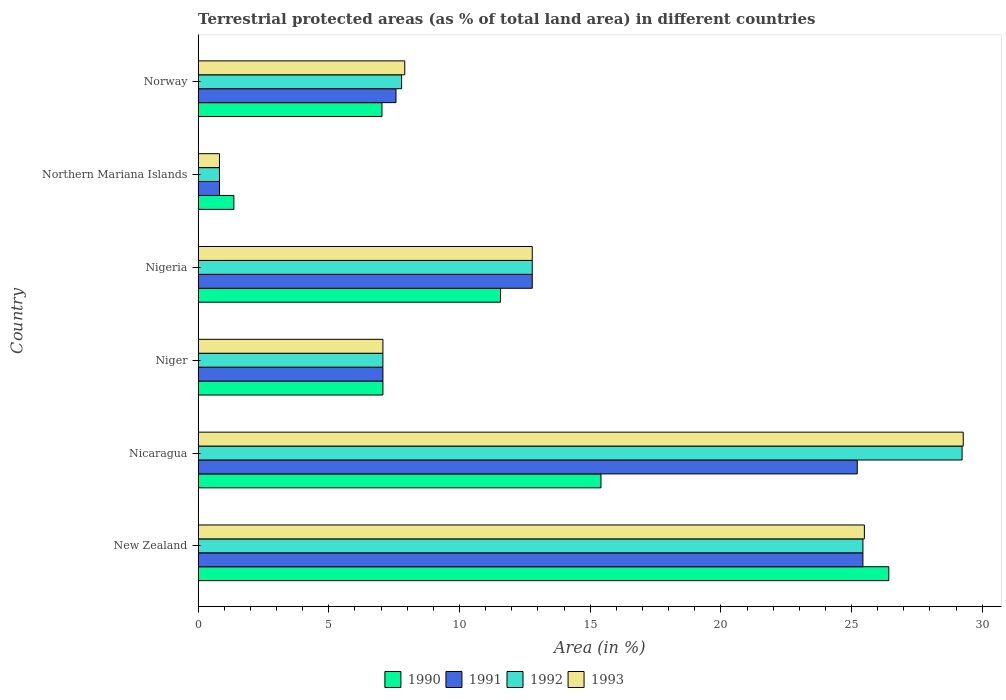How many groups of bars are there?
Keep it short and to the point. 6. How many bars are there on the 1st tick from the top?
Your answer should be compact. 4. How many bars are there on the 5th tick from the bottom?
Keep it short and to the point. 4. What is the label of the 6th group of bars from the top?
Provide a short and direct response. New Zealand. What is the percentage of terrestrial protected land in 1993 in Nigeria?
Offer a very short reply. 12.78. Across all countries, what is the maximum percentage of terrestrial protected land in 1991?
Keep it short and to the point. 25.44. Across all countries, what is the minimum percentage of terrestrial protected land in 1993?
Make the answer very short. 0.82. In which country was the percentage of terrestrial protected land in 1991 maximum?
Make the answer very short. New Zealand. In which country was the percentage of terrestrial protected land in 1991 minimum?
Provide a succinct answer. Northern Mariana Islands. What is the total percentage of terrestrial protected land in 1990 in the graph?
Make the answer very short. 68.88. What is the difference between the percentage of terrestrial protected land in 1993 in New Zealand and that in Nigeria?
Provide a succinct answer. 12.71. What is the difference between the percentage of terrestrial protected land in 1990 in Niger and the percentage of terrestrial protected land in 1991 in Norway?
Provide a succinct answer. -0.5. What is the average percentage of terrestrial protected land in 1990 per country?
Your answer should be compact. 11.48. What is the difference between the percentage of terrestrial protected land in 1991 and percentage of terrestrial protected land in 1992 in New Zealand?
Keep it short and to the point. -0. In how many countries, is the percentage of terrestrial protected land in 1992 greater than 25 %?
Ensure brevity in your answer.  2. What is the ratio of the percentage of terrestrial protected land in 1993 in New Zealand to that in Northern Mariana Islands?
Make the answer very short. 31.27. Is the percentage of terrestrial protected land in 1990 in Northern Mariana Islands less than that in Norway?
Give a very brief answer. Yes. What is the difference between the highest and the second highest percentage of terrestrial protected land in 1993?
Provide a short and direct response. 3.78. What is the difference between the highest and the lowest percentage of terrestrial protected land in 1992?
Provide a succinct answer. 28.41. In how many countries, is the percentage of terrestrial protected land in 1990 greater than the average percentage of terrestrial protected land in 1990 taken over all countries?
Offer a terse response. 3. Is it the case that in every country, the sum of the percentage of terrestrial protected land in 1990 and percentage of terrestrial protected land in 1993 is greater than the sum of percentage of terrestrial protected land in 1992 and percentage of terrestrial protected land in 1991?
Provide a short and direct response. No. What does the 2nd bar from the top in Niger represents?
Make the answer very short. 1992. Are all the bars in the graph horizontal?
Offer a terse response. Yes. How many countries are there in the graph?
Provide a short and direct response. 6. What is the difference between two consecutive major ticks on the X-axis?
Keep it short and to the point. 5. Are the values on the major ticks of X-axis written in scientific E-notation?
Your response must be concise. No. Does the graph contain grids?
Make the answer very short. No. Where does the legend appear in the graph?
Offer a terse response. Bottom center. What is the title of the graph?
Offer a very short reply. Terrestrial protected areas (as % of total land area) in different countries. What is the label or title of the X-axis?
Keep it short and to the point. Area (in %). What is the label or title of the Y-axis?
Make the answer very short. Country. What is the Area (in %) of 1990 in New Zealand?
Make the answer very short. 26.42. What is the Area (in %) in 1991 in New Zealand?
Provide a succinct answer. 25.44. What is the Area (in %) in 1992 in New Zealand?
Provide a succinct answer. 25.44. What is the Area (in %) of 1993 in New Zealand?
Your answer should be compact. 25.49. What is the Area (in %) in 1990 in Nicaragua?
Your answer should be very brief. 15.41. What is the Area (in %) in 1991 in Nicaragua?
Your response must be concise. 25.22. What is the Area (in %) of 1992 in Nicaragua?
Provide a succinct answer. 29.23. What is the Area (in %) in 1993 in Nicaragua?
Keep it short and to the point. 29.27. What is the Area (in %) of 1990 in Niger?
Keep it short and to the point. 7.07. What is the Area (in %) of 1991 in Niger?
Provide a short and direct response. 7.07. What is the Area (in %) in 1992 in Niger?
Make the answer very short. 7.07. What is the Area (in %) of 1993 in Niger?
Offer a very short reply. 7.07. What is the Area (in %) in 1990 in Nigeria?
Your answer should be very brief. 11.57. What is the Area (in %) in 1991 in Nigeria?
Your answer should be compact. 12.78. What is the Area (in %) in 1992 in Nigeria?
Provide a short and direct response. 12.78. What is the Area (in %) of 1993 in Nigeria?
Provide a short and direct response. 12.78. What is the Area (in %) in 1990 in Northern Mariana Islands?
Keep it short and to the point. 1.37. What is the Area (in %) in 1991 in Northern Mariana Islands?
Offer a terse response. 0.82. What is the Area (in %) of 1992 in Northern Mariana Islands?
Provide a succinct answer. 0.82. What is the Area (in %) of 1993 in Northern Mariana Islands?
Ensure brevity in your answer.  0.82. What is the Area (in %) in 1990 in Norway?
Offer a very short reply. 7.03. What is the Area (in %) of 1991 in Norway?
Offer a terse response. 7.57. What is the Area (in %) of 1992 in Norway?
Provide a short and direct response. 7.78. What is the Area (in %) in 1993 in Norway?
Offer a terse response. 7.9. Across all countries, what is the maximum Area (in %) of 1990?
Your answer should be very brief. 26.42. Across all countries, what is the maximum Area (in %) in 1991?
Your answer should be compact. 25.44. Across all countries, what is the maximum Area (in %) of 1992?
Ensure brevity in your answer.  29.23. Across all countries, what is the maximum Area (in %) in 1993?
Make the answer very short. 29.27. Across all countries, what is the minimum Area (in %) of 1990?
Offer a terse response. 1.37. Across all countries, what is the minimum Area (in %) in 1991?
Your answer should be compact. 0.82. Across all countries, what is the minimum Area (in %) of 1992?
Offer a very short reply. 0.82. Across all countries, what is the minimum Area (in %) in 1993?
Offer a terse response. 0.82. What is the total Area (in %) in 1990 in the graph?
Ensure brevity in your answer.  68.88. What is the total Area (in %) in 1991 in the graph?
Provide a succinct answer. 78.89. What is the total Area (in %) of 1992 in the graph?
Offer a very short reply. 83.12. What is the total Area (in %) of 1993 in the graph?
Your answer should be very brief. 83.34. What is the difference between the Area (in %) in 1990 in New Zealand and that in Nicaragua?
Keep it short and to the point. 11.01. What is the difference between the Area (in %) in 1991 in New Zealand and that in Nicaragua?
Provide a succinct answer. 0.22. What is the difference between the Area (in %) in 1992 in New Zealand and that in Nicaragua?
Make the answer very short. -3.79. What is the difference between the Area (in %) in 1993 in New Zealand and that in Nicaragua?
Your answer should be compact. -3.78. What is the difference between the Area (in %) in 1990 in New Zealand and that in Niger?
Give a very brief answer. 19.36. What is the difference between the Area (in %) in 1991 in New Zealand and that in Niger?
Keep it short and to the point. 18.37. What is the difference between the Area (in %) in 1992 in New Zealand and that in Niger?
Provide a short and direct response. 18.37. What is the difference between the Area (in %) in 1993 in New Zealand and that in Niger?
Your answer should be compact. 18.42. What is the difference between the Area (in %) in 1990 in New Zealand and that in Nigeria?
Your answer should be compact. 14.86. What is the difference between the Area (in %) in 1991 in New Zealand and that in Nigeria?
Your answer should be compact. 12.65. What is the difference between the Area (in %) of 1992 in New Zealand and that in Nigeria?
Offer a terse response. 12.65. What is the difference between the Area (in %) of 1993 in New Zealand and that in Nigeria?
Ensure brevity in your answer.  12.71. What is the difference between the Area (in %) in 1990 in New Zealand and that in Northern Mariana Islands?
Keep it short and to the point. 25.06. What is the difference between the Area (in %) of 1991 in New Zealand and that in Northern Mariana Islands?
Your answer should be very brief. 24.62. What is the difference between the Area (in %) in 1992 in New Zealand and that in Northern Mariana Islands?
Make the answer very short. 24.62. What is the difference between the Area (in %) of 1993 in New Zealand and that in Northern Mariana Islands?
Offer a terse response. 24.68. What is the difference between the Area (in %) in 1990 in New Zealand and that in Norway?
Offer a terse response. 19.39. What is the difference between the Area (in %) in 1991 in New Zealand and that in Norway?
Ensure brevity in your answer.  17.87. What is the difference between the Area (in %) of 1992 in New Zealand and that in Norway?
Provide a succinct answer. 17.65. What is the difference between the Area (in %) of 1993 in New Zealand and that in Norway?
Provide a short and direct response. 17.59. What is the difference between the Area (in %) of 1990 in Nicaragua and that in Niger?
Offer a terse response. 8.34. What is the difference between the Area (in %) of 1991 in Nicaragua and that in Niger?
Your answer should be very brief. 18.15. What is the difference between the Area (in %) of 1992 in Nicaragua and that in Niger?
Ensure brevity in your answer.  22.16. What is the difference between the Area (in %) of 1993 in Nicaragua and that in Niger?
Provide a short and direct response. 22.2. What is the difference between the Area (in %) in 1990 in Nicaragua and that in Nigeria?
Provide a succinct answer. 3.84. What is the difference between the Area (in %) of 1991 in Nicaragua and that in Nigeria?
Offer a terse response. 12.44. What is the difference between the Area (in %) of 1992 in Nicaragua and that in Nigeria?
Keep it short and to the point. 16.45. What is the difference between the Area (in %) in 1993 in Nicaragua and that in Nigeria?
Keep it short and to the point. 16.49. What is the difference between the Area (in %) in 1990 in Nicaragua and that in Northern Mariana Islands?
Offer a terse response. 14.05. What is the difference between the Area (in %) of 1991 in Nicaragua and that in Northern Mariana Islands?
Your answer should be compact. 24.4. What is the difference between the Area (in %) in 1992 in Nicaragua and that in Northern Mariana Islands?
Your answer should be compact. 28.41. What is the difference between the Area (in %) of 1993 in Nicaragua and that in Northern Mariana Islands?
Keep it short and to the point. 28.46. What is the difference between the Area (in %) of 1990 in Nicaragua and that in Norway?
Ensure brevity in your answer.  8.38. What is the difference between the Area (in %) of 1991 in Nicaragua and that in Norway?
Keep it short and to the point. 17.65. What is the difference between the Area (in %) of 1992 in Nicaragua and that in Norway?
Your response must be concise. 21.45. What is the difference between the Area (in %) in 1993 in Nicaragua and that in Norway?
Ensure brevity in your answer.  21.37. What is the difference between the Area (in %) of 1991 in Niger and that in Nigeria?
Your answer should be very brief. -5.71. What is the difference between the Area (in %) of 1992 in Niger and that in Nigeria?
Give a very brief answer. -5.71. What is the difference between the Area (in %) in 1993 in Niger and that in Nigeria?
Offer a terse response. -5.71. What is the difference between the Area (in %) of 1990 in Niger and that in Northern Mariana Islands?
Give a very brief answer. 5.7. What is the difference between the Area (in %) in 1991 in Niger and that in Northern Mariana Islands?
Ensure brevity in your answer.  6.25. What is the difference between the Area (in %) of 1992 in Niger and that in Northern Mariana Islands?
Provide a short and direct response. 6.25. What is the difference between the Area (in %) of 1993 in Niger and that in Northern Mariana Islands?
Your answer should be compact. 6.25. What is the difference between the Area (in %) in 1990 in Niger and that in Norway?
Provide a short and direct response. 0.04. What is the difference between the Area (in %) of 1991 in Niger and that in Norway?
Offer a terse response. -0.5. What is the difference between the Area (in %) of 1992 in Niger and that in Norway?
Your answer should be very brief. -0.71. What is the difference between the Area (in %) of 1993 in Niger and that in Norway?
Make the answer very short. -0.84. What is the difference between the Area (in %) in 1990 in Nigeria and that in Northern Mariana Islands?
Give a very brief answer. 10.2. What is the difference between the Area (in %) of 1991 in Nigeria and that in Northern Mariana Islands?
Your response must be concise. 11.97. What is the difference between the Area (in %) in 1992 in Nigeria and that in Northern Mariana Islands?
Your answer should be very brief. 11.97. What is the difference between the Area (in %) in 1993 in Nigeria and that in Northern Mariana Islands?
Give a very brief answer. 11.97. What is the difference between the Area (in %) of 1990 in Nigeria and that in Norway?
Offer a very short reply. 4.54. What is the difference between the Area (in %) of 1991 in Nigeria and that in Norway?
Ensure brevity in your answer.  5.21. What is the difference between the Area (in %) of 1992 in Nigeria and that in Norway?
Keep it short and to the point. 5. What is the difference between the Area (in %) in 1993 in Nigeria and that in Norway?
Give a very brief answer. 4.88. What is the difference between the Area (in %) in 1990 in Northern Mariana Islands and that in Norway?
Offer a terse response. -5.67. What is the difference between the Area (in %) of 1991 in Northern Mariana Islands and that in Norway?
Give a very brief answer. -6.75. What is the difference between the Area (in %) in 1992 in Northern Mariana Islands and that in Norway?
Your answer should be very brief. -6.97. What is the difference between the Area (in %) of 1993 in Northern Mariana Islands and that in Norway?
Ensure brevity in your answer.  -7.09. What is the difference between the Area (in %) in 1990 in New Zealand and the Area (in %) in 1991 in Nicaragua?
Your answer should be compact. 1.21. What is the difference between the Area (in %) in 1990 in New Zealand and the Area (in %) in 1992 in Nicaragua?
Provide a succinct answer. -2.81. What is the difference between the Area (in %) of 1990 in New Zealand and the Area (in %) of 1993 in Nicaragua?
Offer a terse response. -2.85. What is the difference between the Area (in %) in 1991 in New Zealand and the Area (in %) in 1992 in Nicaragua?
Make the answer very short. -3.79. What is the difference between the Area (in %) of 1991 in New Zealand and the Area (in %) of 1993 in Nicaragua?
Give a very brief answer. -3.84. What is the difference between the Area (in %) in 1992 in New Zealand and the Area (in %) in 1993 in Nicaragua?
Your response must be concise. -3.84. What is the difference between the Area (in %) of 1990 in New Zealand and the Area (in %) of 1991 in Niger?
Your response must be concise. 19.36. What is the difference between the Area (in %) in 1990 in New Zealand and the Area (in %) in 1992 in Niger?
Your response must be concise. 19.36. What is the difference between the Area (in %) in 1990 in New Zealand and the Area (in %) in 1993 in Niger?
Your answer should be very brief. 19.36. What is the difference between the Area (in %) of 1991 in New Zealand and the Area (in %) of 1992 in Niger?
Ensure brevity in your answer.  18.37. What is the difference between the Area (in %) in 1991 in New Zealand and the Area (in %) in 1993 in Niger?
Your answer should be very brief. 18.37. What is the difference between the Area (in %) of 1992 in New Zealand and the Area (in %) of 1993 in Niger?
Your answer should be very brief. 18.37. What is the difference between the Area (in %) of 1990 in New Zealand and the Area (in %) of 1991 in Nigeria?
Your answer should be compact. 13.64. What is the difference between the Area (in %) of 1990 in New Zealand and the Area (in %) of 1992 in Nigeria?
Your answer should be very brief. 13.64. What is the difference between the Area (in %) in 1990 in New Zealand and the Area (in %) in 1993 in Nigeria?
Your response must be concise. 13.64. What is the difference between the Area (in %) of 1991 in New Zealand and the Area (in %) of 1992 in Nigeria?
Your response must be concise. 12.65. What is the difference between the Area (in %) of 1991 in New Zealand and the Area (in %) of 1993 in Nigeria?
Keep it short and to the point. 12.65. What is the difference between the Area (in %) in 1992 in New Zealand and the Area (in %) in 1993 in Nigeria?
Offer a terse response. 12.65. What is the difference between the Area (in %) in 1990 in New Zealand and the Area (in %) in 1991 in Northern Mariana Islands?
Make the answer very short. 25.61. What is the difference between the Area (in %) in 1990 in New Zealand and the Area (in %) in 1992 in Northern Mariana Islands?
Your response must be concise. 25.61. What is the difference between the Area (in %) of 1990 in New Zealand and the Area (in %) of 1993 in Northern Mariana Islands?
Your answer should be compact. 25.61. What is the difference between the Area (in %) of 1991 in New Zealand and the Area (in %) of 1992 in Northern Mariana Islands?
Ensure brevity in your answer.  24.62. What is the difference between the Area (in %) in 1991 in New Zealand and the Area (in %) in 1993 in Northern Mariana Islands?
Offer a very short reply. 24.62. What is the difference between the Area (in %) of 1992 in New Zealand and the Area (in %) of 1993 in Northern Mariana Islands?
Offer a very short reply. 24.62. What is the difference between the Area (in %) in 1990 in New Zealand and the Area (in %) in 1991 in Norway?
Provide a short and direct response. 18.86. What is the difference between the Area (in %) of 1990 in New Zealand and the Area (in %) of 1992 in Norway?
Keep it short and to the point. 18.64. What is the difference between the Area (in %) of 1990 in New Zealand and the Area (in %) of 1993 in Norway?
Provide a succinct answer. 18.52. What is the difference between the Area (in %) of 1991 in New Zealand and the Area (in %) of 1992 in Norway?
Provide a short and direct response. 17.65. What is the difference between the Area (in %) in 1991 in New Zealand and the Area (in %) in 1993 in Norway?
Your answer should be compact. 17.53. What is the difference between the Area (in %) of 1992 in New Zealand and the Area (in %) of 1993 in Norway?
Offer a very short reply. 17.53. What is the difference between the Area (in %) in 1990 in Nicaragua and the Area (in %) in 1991 in Niger?
Give a very brief answer. 8.34. What is the difference between the Area (in %) of 1990 in Nicaragua and the Area (in %) of 1992 in Niger?
Provide a succinct answer. 8.34. What is the difference between the Area (in %) of 1990 in Nicaragua and the Area (in %) of 1993 in Niger?
Keep it short and to the point. 8.34. What is the difference between the Area (in %) in 1991 in Nicaragua and the Area (in %) in 1992 in Niger?
Give a very brief answer. 18.15. What is the difference between the Area (in %) of 1991 in Nicaragua and the Area (in %) of 1993 in Niger?
Your response must be concise. 18.15. What is the difference between the Area (in %) in 1992 in Nicaragua and the Area (in %) in 1993 in Niger?
Keep it short and to the point. 22.16. What is the difference between the Area (in %) in 1990 in Nicaragua and the Area (in %) in 1991 in Nigeria?
Your answer should be compact. 2.63. What is the difference between the Area (in %) of 1990 in Nicaragua and the Area (in %) of 1992 in Nigeria?
Your answer should be very brief. 2.63. What is the difference between the Area (in %) of 1990 in Nicaragua and the Area (in %) of 1993 in Nigeria?
Offer a very short reply. 2.63. What is the difference between the Area (in %) in 1991 in Nicaragua and the Area (in %) in 1992 in Nigeria?
Your answer should be compact. 12.44. What is the difference between the Area (in %) in 1991 in Nicaragua and the Area (in %) in 1993 in Nigeria?
Provide a succinct answer. 12.44. What is the difference between the Area (in %) in 1992 in Nicaragua and the Area (in %) in 1993 in Nigeria?
Provide a succinct answer. 16.45. What is the difference between the Area (in %) in 1990 in Nicaragua and the Area (in %) in 1991 in Northern Mariana Islands?
Keep it short and to the point. 14.6. What is the difference between the Area (in %) in 1990 in Nicaragua and the Area (in %) in 1992 in Northern Mariana Islands?
Keep it short and to the point. 14.6. What is the difference between the Area (in %) in 1990 in Nicaragua and the Area (in %) in 1993 in Northern Mariana Islands?
Offer a very short reply. 14.6. What is the difference between the Area (in %) in 1991 in Nicaragua and the Area (in %) in 1992 in Northern Mariana Islands?
Provide a succinct answer. 24.4. What is the difference between the Area (in %) of 1991 in Nicaragua and the Area (in %) of 1993 in Northern Mariana Islands?
Offer a terse response. 24.4. What is the difference between the Area (in %) of 1992 in Nicaragua and the Area (in %) of 1993 in Northern Mariana Islands?
Offer a terse response. 28.41. What is the difference between the Area (in %) of 1990 in Nicaragua and the Area (in %) of 1991 in Norway?
Offer a terse response. 7.84. What is the difference between the Area (in %) in 1990 in Nicaragua and the Area (in %) in 1992 in Norway?
Provide a short and direct response. 7.63. What is the difference between the Area (in %) in 1990 in Nicaragua and the Area (in %) in 1993 in Norway?
Your answer should be very brief. 7.51. What is the difference between the Area (in %) in 1991 in Nicaragua and the Area (in %) in 1992 in Norway?
Ensure brevity in your answer.  17.43. What is the difference between the Area (in %) of 1991 in Nicaragua and the Area (in %) of 1993 in Norway?
Provide a succinct answer. 17.31. What is the difference between the Area (in %) of 1992 in Nicaragua and the Area (in %) of 1993 in Norway?
Provide a short and direct response. 21.33. What is the difference between the Area (in %) of 1990 in Niger and the Area (in %) of 1991 in Nigeria?
Make the answer very short. -5.71. What is the difference between the Area (in %) in 1990 in Niger and the Area (in %) in 1992 in Nigeria?
Provide a succinct answer. -5.71. What is the difference between the Area (in %) of 1990 in Niger and the Area (in %) of 1993 in Nigeria?
Your answer should be compact. -5.71. What is the difference between the Area (in %) of 1991 in Niger and the Area (in %) of 1992 in Nigeria?
Your answer should be compact. -5.71. What is the difference between the Area (in %) in 1991 in Niger and the Area (in %) in 1993 in Nigeria?
Ensure brevity in your answer.  -5.71. What is the difference between the Area (in %) in 1992 in Niger and the Area (in %) in 1993 in Nigeria?
Offer a very short reply. -5.71. What is the difference between the Area (in %) of 1990 in Niger and the Area (in %) of 1991 in Northern Mariana Islands?
Provide a succinct answer. 6.25. What is the difference between the Area (in %) in 1990 in Niger and the Area (in %) in 1992 in Northern Mariana Islands?
Provide a succinct answer. 6.25. What is the difference between the Area (in %) of 1990 in Niger and the Area (in %) of 1993 in Northern Mariana Islands?
Your response must be concise. 6.25. What is the difference between the Area (in %) in 1991 in Niger and the Area (in %) in 1992 in Northern Mariana Islands?
Keep it short and to the point. 6.25. What is the difference between the Area (in %) of 1991 in Niger and the Area (in %) of 1993 in Northern Mariana Islands?
Make the answer very short. 6.25. What is the difference between the Area (in %) in 1992 in Niger and the Area (in %) in 1993 in Northern Mariana Islands?
Provide a short and direct response. 6.25. What is the difference between the Area (in %) in 1990 in Niger and the Area (in %) in 1991 in Norway?
Your answer should be compact. -0.5. What is the difference between the Area (in %) of 1990 in Niger and the Area (in %) of 1992 in Norway?
Offer a terse response. -0.71. What is the difference between the Area (in %) in 1990 in Niger and the Area (in %) in 1993 in Norway?
Ensure brevity in your answer.  -0.84. What is the difference between the Area (in %) in 1991 in Niger and the Area (in %) in 1992 in Norway?
Keep it short and to the point. -0.71. What is the difference between the Area (in %) in 1991 in Niger and the Area (in %) in 1993 in Norway?
Keep it short and to the point. -0.84. What is the difference between the Area (in %) of 1992 in Niger and the Area (in %) of 1993 in Norway?
Give a very brief answer. -0.84. What is the difference between the Area (in %) in 1990 in Nigeria and the Area (in %) in 1991 in Northern Mariana Islands?
Your answer should be compact. 10.75. What is the difference between the Area (in %) of 1990 in Nigeria and the Area (in %) of 1992 in Northern Mariana Islands?
Your response must be concise. 10.75. What is the difference between the Area (in %) in 1990 in Nigeria and the Area (in %) in 1993 in Northern Mariana Islands?
Your answer should be compact. 10.75. What is the difference between the Area (in %) in 1991 in Nigeria and the Area (in %) in 1992 in Northern Mariana Islands?
Provide a short and direct response. 11.97. What is the difference between the Area (in %) in 1991 in Nigeria and the Area (in %) in 1993 in Northern Mariana Islands?
Provide a succinct answer. 11.97. What is the difference between the Area (in %) of 1992 in Nigeria and the Area (in %) of 1993 in Northern Mariana Islands?
Keep it short and to the point. 11.97. What is the difference between the Area (in %) in 1990 in Nigeria and the Area (in %) in 1991 in Norway?
Keep it short and to the point. 4. What is the difference between the Area (in %) in 1990 in Nigeria and the Area (in %) in 1992 in Norway?
Offer a terse response. 3.79. What is the difference between the Area (in %) of 1990 in Nigeria and the Area (in %) of 1993 in Norway?
Give a very brief answer. 3.66. What is the difference between the Area (in %) in 1991 in Nigeria and the Area (in %) in 1992 in Norway?
Your response must be concise. 5. What is the difference between the Area (in %) of 1991 in Nigeria and the Area (in %) of 1993 in Norway?
Ensure brevity in your answer.  4.88. What is the difference between the Area (in %) of 1992 in Nigeria and the Area (in %) of 1993 in Norway?
Ensure brevity in your answer.  4.88. What is the difference between the Area (in %) of 1990 in Northern Mariana Islands and the Area (in %) of 1991 in Norway?
Keep it short and to the point. -6.2. What is the difference between the Area (in %) of 1990 in Northern Mariana Islands and the Area (in %) of 1992 in Norway?
Give a very brief answer. -6.42. What is the difference between the Area (in %) in 1990 in Northern Mariana Islands and the Area (in %) in 1993 in Norway?
Your answer should be very brief. -6.54. What is the difference between the Area (in %) of 1991 in Northern Mariana Islands and the Area (in %) of 1992 in Norway?
Your answer should be compact. -6.97. What is the difference between the Area (in %) of 1991 in Northern Mariana Islands and the Area (in %) of 1993 in Norway?
Give a very brief answer. -7.09. What is the difference between the Area (in %) in 1992 in Northern Mariana Islands and the Area (in %) in 1993 in Norway?
Provide a short and direct response. -7.09. What is the average Area (in %) of 1990 per country?
Ensure brevity in your answer.  11.48. What is the average Area (in %) of 1991 per country?
Your answer should be very brief. 13.15. What is the average Area (in %) in 1992 per country?
Make the answer very short. 13.85. What is the average Area (in %) in 1993 per country?
Make the answer very short. 13.89. What is the difference between the Area (in %) of 1990 and Area (in %) of 1992 in New Zealand?
Offer a very short reply. 0.99. What is the difference between the Area (in %) in 1990 and Area (in %) in 1993 in New Zealand?
Provide a succinct answer. 0.93. What is the difference between the Area (in %) in 1991 and Area (in %) in 1992 in New Zealand?
Offer a very short reply. -0. What is the difference between the Area (in %) in 1991 and Area (in %) in 1993 in New Zealand?
Offer a terse response. -0.06. What is the difference between the Area (in %) in 1992 and Area (in %) in 1993 in New Zealand?
Provide a short and direct response. -0.06. What is the difference between the Area (in %) of 1990 and Area (in %) of 1991 in Nicaragua?
Keep it short and to the point. -9.81. What is the difference between the Area (in %) in 1990 and Area (in %) in 1992 in Nicaragua?
Ensure brevity in your answer.  -13.82. What is the difference between the Area (in %) in 1990 and Area (in %) in 1993 in Nicaragua?
Offer a terse response. -13.86. What is the difference between the Area (in %) of 1991 and Area (in %) of 1992 in Nicaragua?
Give a very brief answer. -4.01. What is the difference between the Area (in %) in 1991 and Area (in %) in 1993 in Nicaragua?
Offer a very short reply. -4.06. What is the difference between the Area (in %) of 1992 and Area (in %) of 1993 in Nicaragua?
Make the answer very short. -0.04. What is the difference between the Area (in %) in 1990 and Area (in %) in 1993 in Niger?
Provide a succinct answer. 0. What is the difference between the Area (in %) in 1991 and Area (in %) in 1992 in Niger?
Keep it short and to the point. 0. What is the difference between the Area (in %) in 1991 and Area (in %) in 1993 in Niger?
Provide a succinct answer. 0. What is the difference between the Area (in %) of 1990 and Area (in %) of 1991 in Nigeria?
Ensure brevity in your answer.  -1.21. What is the difference between the Area (in %) in 1990 and Area (in %) in 1992 in Nigeria?
Your answer should be compact. -1.21. What is the difference between the Area (in %) of 1990 and Area (in %) of 1993 in Nigeria?
Your answer should be very brief. -1.21. What is the difference between the Area (in %) of 1991 and Area (in %) of 1993 in Nigeria?
Make the answer very short. 0. What is the difference between the Area (in %) in 1990 and Area (in %) in 1991 in Northern Mariana Islands?
Give a very brief answer. 0.55. What is the difference between the Area (in %) in 1990 and Area (in %) in 1992 in Northern Mariana Islands?
Keep it short and to the point. 0.55. What is the difference between the Area (in %) of 1990 and Area (in %) of 1993 in Northern Mariana Islands?
Make the answer very short. 0.55. What is the difference between the Area (in %) in 1991 and Area (in %) in 1992 in Northern Mariana Islands?
Your answer should be very brief. 0. What is the difference between the Area (in %) of 1992 and Area (in %) of 1993 in Northern Mariana Islands?
Provide a short and direct response. 0. What is the difference between the Area (in %) in 1990 and Area (in %) in 1991 in Norway?
Offer a terse response. -0.54. What is the difference between the Area (in %) in 1990 and Area (in %) in 1992 in Norway?
Your answer should be compact. -0.75. What is the difference between the Area (in %) of 1990 and Area (in %) of 1993 in Norway?
Make the answer very short. -0.87. What is the difference between the Area (in %) in 1991 and Area (in %) in 1992 in Norway?
Your response must be concise. -0.21. What is the difference between the Area (in %) in 1991 and Area (in %) in 1993 in Norway?
Offer a very short reply. -0.34. What is the difference between the Area (in %) of 1992 and Area (in %) of 1993 in Norway?
Provide a short and direct response. -0.12. What is the ratio of the Area (in %) of 1990 in New Zealand to that in Nicaragua?
Provide a succinct answer. 1.71. What is the ratio of the Area (in %) of 1991 in New Zealand to that in Nicaragua?
Keep it short and to the point. 1.01. What is the ratio of the Area (in %) of 1992 in New Zealand to that in Nicaragua?
Make the answer very short. 0.87. What is the ratio of the Area (in %) in 1993 in New Zealand to that in Nicaragua?
Your answer should be compact. 0.87. What is the ratio of the Area (in %) in 1990 in New Zealand to that in Niger?
Give a very brief answer. 3.74. What is the ratio of the Area (in %) in 1991 in New Zealand to that in Niger?
Give a very brief answer. 3.6. What is the ratio of the Area (in %) in 1992 in New Zealand to that in Niger?
Make the answer very short. 3.6. What is the ratio of the Area (in %) in 1993 in New Zealand to that in Niger?
Keep it short and to the point. 3.61. What is the ratio of the Area (in %) of 1990 in New Zealand to that in Nigeria?
Keep it short and to the point. 2.28. What is the ratio of the Area (in %) of 1991 in New Zealand to that in Nigeria?
Offer a terse response. 1.99. What is the ratio of the Area (in %) in 1992 in New Zealand to that in Nigeria?
Provide a short and direct response. 1.99. What is the ratio of the Area (in %) of 1993 in New Zealand to that in Nigeria?
Ensure brevity in your answer.  1.99. What is the ratio of the Area (in %) in 1990 in New Zealand to that in Northern Mariana Islands?
Provide a succinct answer. 19.34. What is the ratio of the Area (in %) of 1991 in New Zealand to that in Northern Mariana Islands?
Your answer should be very brief. 31.2. What is the ratio of the Area (in %) of 1992 in New Zealand to that in Northern Mariana Islands?
Offer a terse response. 31.2. What is the ratio of the Area (in %) of 1993 in New Zealand to that in Northern Mariana Islands?
Offer a terse response. 31.27. What is the ratio of the Area (in %) in 1990 in New Zealand to that in Norway?
Ensure brevity in your answer.  3.76. What is the ratio of the Area (in %) of 1991 in New Zealand to that in Norway?
Offer a very short reply. 3.36. What is the ratio of the Area (in %) in 1992 in New Zealand to that in Norway?
Give a very brief answer. 3.27. What is the ratio of the Area (in %) of 1993 in New Zealand to that in Norway?
Your answer should be very brief. 3.22. What is the ratio of the Area (in %) of 1990 in Nicaragua to that in Niger?
Your answer should be compact. 2.18. What is the ratio of the Area (in %) of 1991 in Nicaragua to that in Niger?
Make the answer very short. 3.57. What is the ratio of the Area (in %) of 1992 in Nicaragua to that in Niger?
Offer a terse response. 4.13. What is the ratio of the Area (in %) of 1993 in Nicaragua to that in Niger?
Offer a very short reply. 4.14. What is the ratio of the Area (in %) of 1990 in Nicaragua to that in Nigeria?
Provide a short and direct response. 1.33. What is the ratio of the Area (in %) of 1991 in Nicaragua to that in Nigeria?
Provide a succinct answer. 1.97. What is the ratio of the Area (in %) in 1992 in Nicaragua to that in Nigeria?
Give a very brief answer. 2.29. What is the ratio of the Area (in %) of 1993 in Nicaragua to that in Nigeria?
Offer a terse response. 2.29. What is the ratio of the Area (in %) in 1990 in Nicaragua to that in Northern Mariana Islands?
Your response must be concise. 11.28. What is the ratio of the Area (in %) in 1991 in Nicaragua to that in Northern Mariana Islands?
Provide a succinct answer. 30.93. What is the ratio of the Area (in %) of 1992 in Nicaragua to that in Northern Mariana Islands?
Offer a very short reply. 35.85. What is the ratio of the Area (in %) in 1993 in Nicaragua to that in Northern Mariana Islands?
Ensure brevity in your answer.  35.91. What is the ratio of the Area (in %) in 1990 in Nicaragua to that in Norway?
Keep it short and to the point. 2.19. What is the ratio of the Area (in %) in 1991 in Nicaragua to that in Norway?
Make the answer very short. 3.33. What is the ratio of the Area (in %) in 1992 in Nicaragua to that in Norway?
Make the answer very short. 3.76. What is the ratio of the Area (in %) of 1993 in Nicaragua to that in Norway?
Give a very brief answer. 3.7. What is the ratio of the Area (in %) of 1990 in Niger to that in Nigeria?
Give a very brief answer. 0.61. What is the ratio of the Area (in %) of 1991 in Niger to that in Nigeria?
Keep it short and to the point. 0.55. What is the ratio of the Area (in %) in 1992 in Niger to that in Nigeria?
Provide a succinct answer. 0.55. What is the ratio of the Area (in %) of 1993 in Niger to that in Nigeria?
Provide a succinct answer. 0.55. What is the ratio of the Area (in %) of 1990 in Niger to that in Northern Mariana Islands?
Offer a terse response. 5.17. What is the ratio of the Area (in %) in 1991 in Niger to that in Northern Mariana Islands?
Your response must be concise. 8.67. What is the ratio of the Area (in %) of 1992 in Niger to that in Northern Mariana Islands?
Your answer should be very brief. 8.67. What is the ratio of the Area (in %) of 1993 in Niger to that in Northern Mariana Islands?
Your answer should be very brief. 8.67. What is the ratio of the Area (in %) of 1990 in Niger to that in Norway?
Your answer should be compact. 1.01. What is the ratio of the Area (in %) of 1991 in Niger to that in Norway?
Your response must be concise. 0.93. What is the ratio of the Area (in %) of 1992 in Niger to that in Norway?
Offer a very short reply. 0.91. What is the ratio of the Area (in %) in 1993 in Niger to that in Norway?
Make the answer very short. 0.89. What is the ratio of the Area (in %) of 1990 in Nigeria to that in Northern Mariana Islands?
Make the answer very short. 8.47. What is the ratio of the Area (in %) of 1991 in Nigeria to that in Northern Mariana Islands?
Offer a terse response. 15.68. What is the ratio of the Area (in %) of 1992 in Nigeria to that in Northern Mariana Islands?
Ensure brevity in your answer.  15.68. What is the ratio of the Area (in %) of 1993 in Nigeria to that in Northern Mariana Islands?
Give a very brief answer. 15.68. What is the ratio of the Area (in %) in 1990 in Nigeria to that in Norway?
Your answer should be compact. 1.65. What is the ratio of the Area (in %) in 1991 in Nigeria to that in Norway?
Give a very brief answer. 1.69. What is the ratio of the Area (in %) of 1992 in Nigeria to that in Norway?
Provide a succinct answer. 1.64. What is the ratio of the Area (in %) of 1993 in Nigeria to that in Norway?
Make the answer very short. 1.62. What is the ratio of the Area (in %) in 1990 in Northern Mariana Islands to that in Norway?
Your answer should be very brief. 0.19. What is the ratio of the Area (in %) in 1991 in Northern Mariana Islands to that in Norway?
Offer a terse response. 0.11. What is the ratio of the Area (in %) in 1992 in Northern Mariana Islands to that in Norway?
Give a very brief answer. 0.1. What is the ratio of the Area (in %) in 1993 in Northern Mariana Islands to that in Norway?
Provide a succinct answer. 0.1. What is the difference between the highest and the second highest Area (in %) in 1990?
Keep it short and to the point. 11.01. What is the difference between the highest and the second highest Area (in %) of 1991?
Make the answer very short. 0.22. What is the difference between the highest and the second highest Area (in %) in 1992?
Ensure brevity in your answer.  3.79. What is the difference between the highest and the second highest Area (in %) in 1993?
Ensure brevity in your answer.  3.78. What is the difference between the highest and the lowest Area (in %) in 1990?
Offer a terse response. 25.06. What is the difference between the highest and the lowest Area (in %) in 1991?
Your answer should be compact. 24.62. What is the difference between the highest and the lowest Area (in %) in 1992?
Offer a very short reply. 28.41. What is the difference between the highest and the lowest Area (in %) of 1993?
Give a very brief answer. 28.46. 